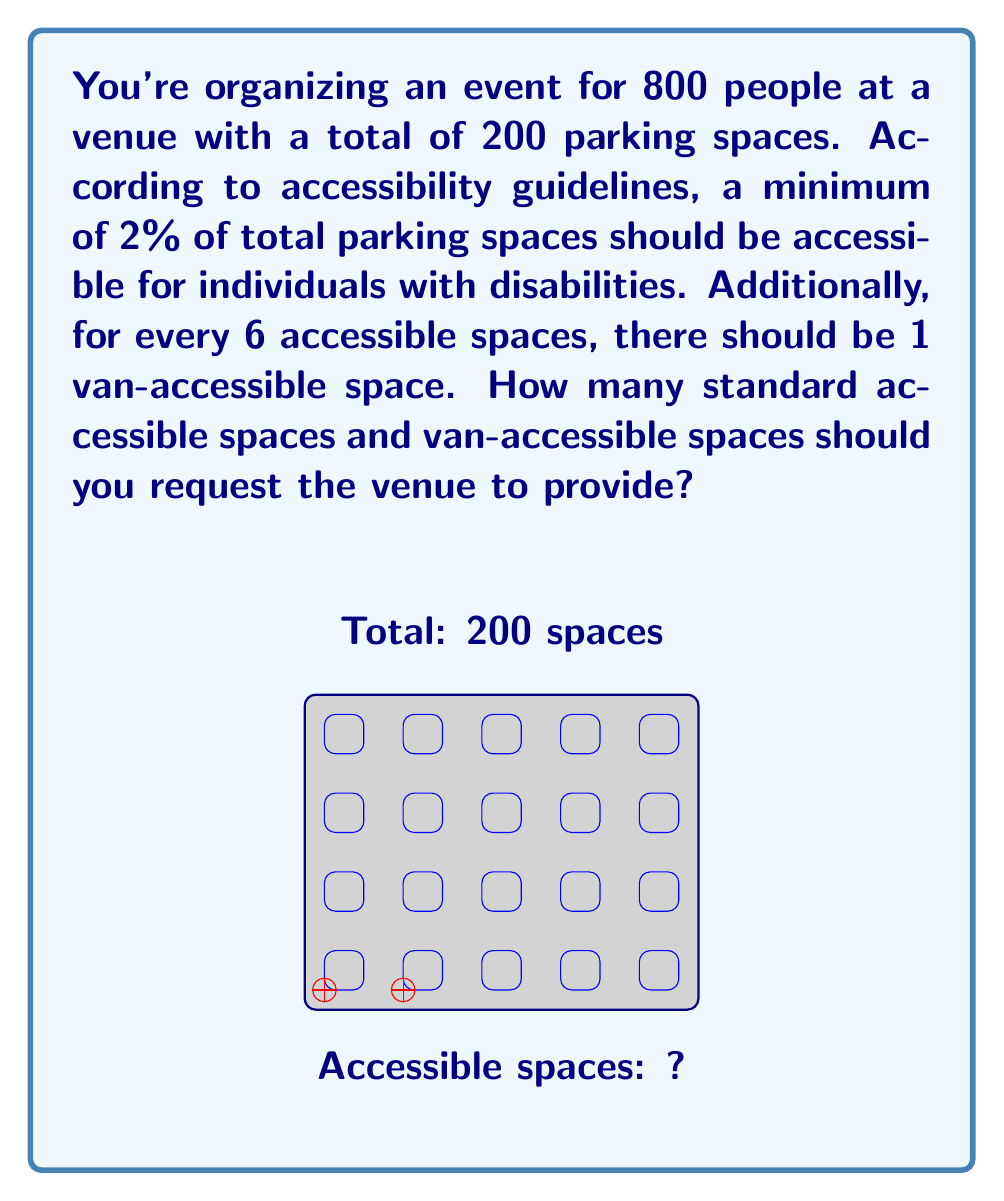Help me with this question. Let's approach this problem step-by-step:

1) First, calculate the minimum number of accessible spaces required:
   $$\text{Minimum accessible spaces} = 2\% \times \text{Total parking spaces}$$
   $$= 0.02 \times 200 = 4 \text{ spaces}$$

2) Now, determine how many of these should be van-accessible:
   $$\text{Van-accessible spaces} = \frac{\text{Total accessible spaces}}{6} \text{ (rounded up)}$$
   $$= \frac{4}{6} \approx 0.67, \text{ which rounds up to 1}$$

3) Calculate the number of standard accessible spaces:
   $$\text{Standard accessible spaces} = \text{Total accessible spaces} - \text{Van-accessible spaces}$$
   $$= 4 - 1 = 3 \text{ spaces}$$

Therefore, you should request the venue to provide 3 standard accessible spaces and 1 van-accessible space.
Answer: 3 standard, 1 van-accessible 